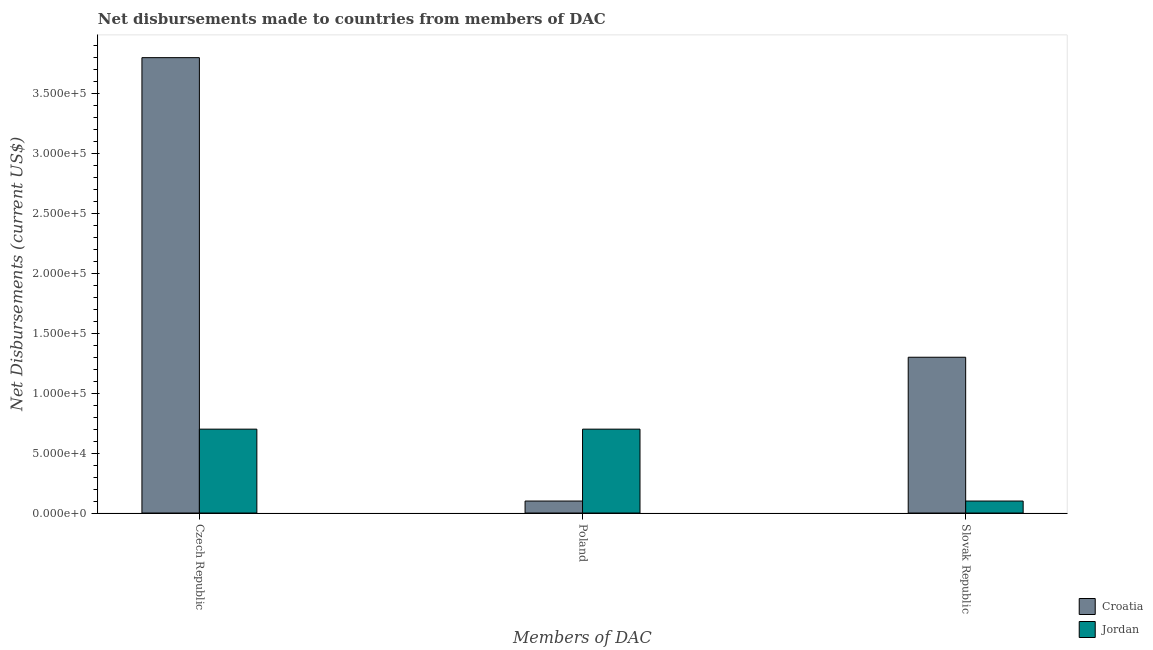How many different coloured bars are there?
Provide a succinct answer. 2. How many groups of bars are there?
Offer a terse response. 3. What is the label of the 1st group of bars from the left?
Give a very brief answer. Czech Republic. What is the net disbursements made by poland in Jordan?
Your answer should be compact. 7.00e+04. Across all countries, what is the maximum net disbursements made by czech republic?
Your answer should be compact. 3.80e+05. Across all countries, what is the minimum net disbursements made by czech republic?
Give a very brief answer. 7.00e+04. In which country was the net disbursements made by slovak republic maximum?
Offer a terse response. Croatia. In which country was the net disbursements made by czech republic minimum?
Your answer should be very brief. Jordan. What is the total net disbursements made by poland in the graph?
Offer a very short reply. 8.00e+04. What is the difference between the net disbursements made by poland in Jordan and that in Croatia?
Your answer should be compact. 6.00e+04. What is the difference between the net disbursements made by czech republic in Jordan and the net disbursements made by poland in Croatia?
Provide a succinct answer. 6.00e+04. What is the average net disbursements made by czech republic per country?
Offer a terse response. 2.25e+05. What is the difference between the net disbursements made by slovak republic and net disbursements made by poland in Jordan?
Provide a succinct answer. -6.00e+04. In how many countries, is the net disbursements made by poland greater than 190000 US$?
Your answer should be very brief. 0. What is the ratio of the net disbursements made by czech republic in Jordan to that in Croatia?
Keep it short and to the point. 0.18. Is the net disbursements made by poland in Jordan less than that in Croatia?
Give a very brief answer. No. Is the difference between the net disbursements made by slovak republic in Croatia and Jordan greater than the difference between the net disbursements made by czech republic in Croatia and Jordan?
Provide a succinct answer. No. What is the difference between the highest and the second highest net disbursements made by poland?
Provide a succinct answer. 6.00e+04. What is the difference between the highest and the lowest net disbursements made by poland?
Provide a short and direct response. 6.00e+04. In how many countries, is the net disbursements made by poland greater than the average net disbursements made by poland taken over all countries?
Your answer should be very brief. 1. What does the 2nd bar from the left in Slovak Republic represents?
Make the answer very short. Jordan. What does the 1st bar from the right in Slovak Republic represents?
Make the answer very short. Jordan. Is it the case that in every country, the sum of the net disbursements made by czech republic and net disbursements made by poland is greater than the net disbursements made by slovak republic?
Provide a short and direct response. Yes. How many bars are there?
Your answer should be compact. 6. What is the difference between two consecutive major ticks on the Y-axis?
Give a very brief answer. 5.00e+04. Does the graph contain any zero values?
Your answer should be very brief. No. Does the graph contain grids?
Your response must be concise. No. How many legend labels are there?
Ensure brevity in your answer.  2. How are the legend labels stacked?
Provide a succinct answer. Vertical. What is the title of the graph?
Give a very brief answer. Net disbursements made to countries from members of DAC. Does "Cayman Islands" appear as one of the legend labels in the graph?
Your answer should be compact. No. What is the label or title of the X-axis?
Your answer should be very brief. Members of DAC. What is the label or title of the Y-axis?
Your answer should be very brief. Net Disbursements (current US$). What is the Net Disbursements (current US$) in Croatia in Czech Republic?
Your answer should be very brief. 3.80e+05. What is the Net Disbursements (current US$) in Croatia in Poland?
Your response must be concise. 10000. Across all Members of DAC, what is the maximum Net Disbursements (current US$) in Jordan?
Your answer should be compact. 7.00e+04. What is the total Net Disbursements (current US$) in Croatia in the graph?
Your answer should be compact. 5.20e+05. What is the difference between the Net Disbursements (current US$) in Jordan in Czech Republic and that in Slovak Republic?
Make the answer very short. 6.00e+04. What is the difference between the Net Disbursements (current US$) in Croatia in Poland and that in Slovak Republic?
Your response must be concise. -1.20e+05. What is the difference between the Net Disbursements (current US$) in Croatia in Czech Republic and the Net Disbursements (current US$) in Jordan in Poland?
Your answer should be compact. 3.10e+05. What is the difference between the Net Disbursements (current US$) in Croatia in Czech Republic and the Net Disbursements (current US$) in Jordan in Slovak Republic?
Your answer should be very brief. 3.70e+05. What is the average Net Disbursements (current US$) in Croatia per Members of DAC?
Your answer should be very brief. 1.73e+05. What is the average Net Disbursements (current US$) of Jordan per Members of DAC?
Provide a short and direct response. 5.00e+04. What is the difference between the Net Disbursements (current US$) of Croatia and Net Disbursements (current US$) of Jordan in Slovak Republic?
Make the answer very short. 1.20e+05. What is the ratio of the Net Disbursements (current US$) in Croatia in Czech Republic to that in Poland?
Make the answer very short. 38. What is the ratio of the Net Disbursements (current US$) of Croatia in Czech Republic to that in Slovak Republic?
Ensure brevity in your answer.  2.92. What is the ratio of the Net Disbursements (current US$) of Jordan in Czech Republic to that in Slovak Republic?
Make the answer very short. 7. What is the ratio of the Net Disbursements (current US$) in Croatia in Poland to that in Slovak Republic?
Offer a terse response. 0.08. What is the difference between the highest and the second highest Net Disbursements (current US$) in Croatia?
Provide a succinct answer. 2.50e+05. What is the difference between the highest and the second highest Net Disbursements (current US$) of Jordan?
Give a very brief answer. 0. What is the difference between the highest and the lowest Net Disbursements (current US$) in Croatia?
Your response must be concise. 3.70e+05. What is the difference between the highest and the lowest Net Disbursements (current US$) of Jordan?
Ensure brevity in your answer.  6.00e+04. 